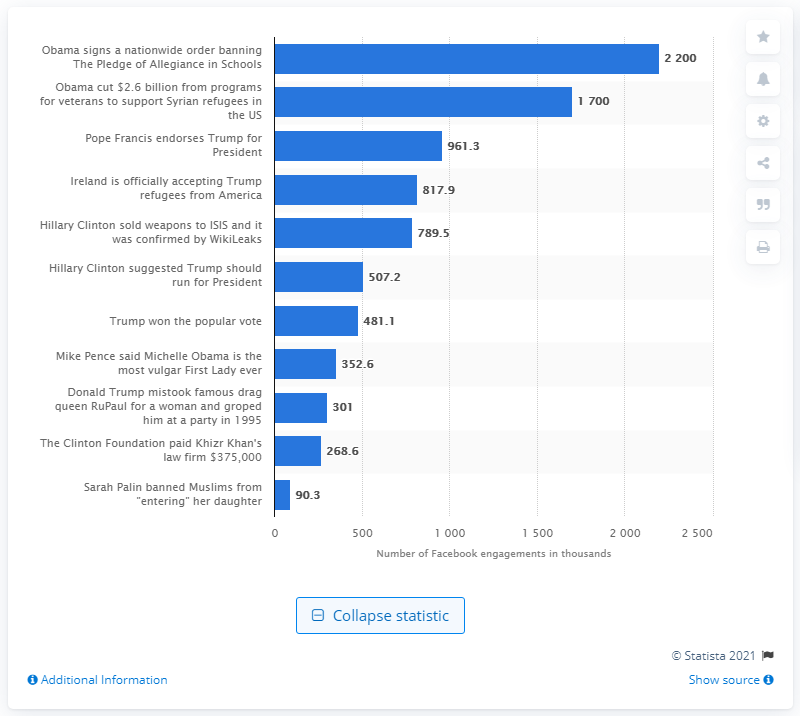How many times was the fake news story shared on Facebook in the three months leading up to the election?
 2200 